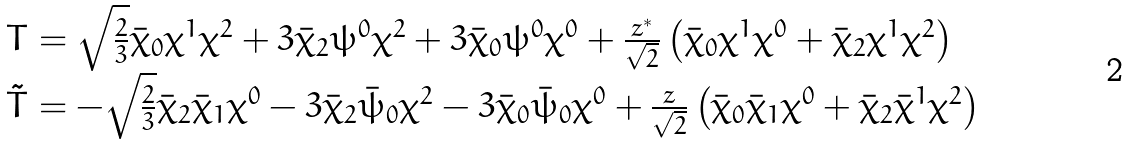<formula> <loc_0><loc_0><loc_500><loc_500>\begin{array} { l } T = \sqrt { \frac { 2 } { 3 } } \bar { \chi } _ { 0 } \chi ^ { 1 } \chi ^ { 2 } + 3 \bar { \chi } _ { 2 } \psi ^ { 0 } \chi ^ { 2 } + 3 \bar { \chi } _ { 0 } \psi ^ { 0 } \chi ^ { 0 } + \frac { z ^ { * } } { \sqrt { 2 } } \left ( \bar { \chi } _ { 0 } \chi ^ { 1 } \chi ^ { 0 } + \bar { \chi } _ { 2 } \chi ^ { 1 } \chi ^ { 2 } \right ) \\ \tilde { T } = - \sqrt { \frac { 2 } { 3 } } \bar { \chi } _ { 2 } \bar { \chi } _ { 1 } \chi ^ { 0 } - 3 \bar { \chi } _ { 2 } \bar { \psi } _ { 0 } \chi ^ { 2 } - 3 \bar { \chi } _ { 0 } \bar { \psi } _ { 0 } \chi ^ { 0 } + \frac { z } { \sqrt { 2 } } \left ( \bar { \chi } _ { 0 } \bar { \chi } _ { 1 } \chi ^ { 0 } + \bar { \chi } _ { 2 } \bar { \chi } ^ { 1 } \chi ^ { 2 } \right ) \end{array}</formula> 